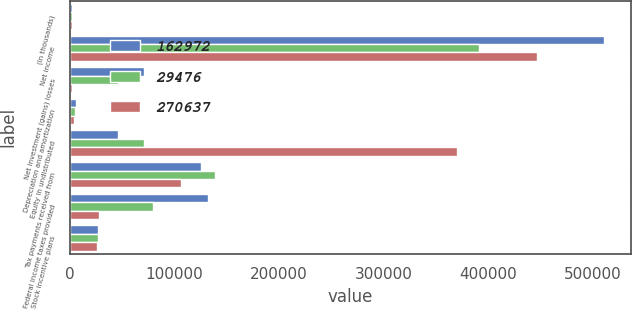<chart> <loc_0><loc_0><loc_500><loc_500><stacked_bar_chart><ecel><fcel>(In thousands)<fcel>Net income<fcel>Net investment (gains) losses<fcel>Depreciation and amortization<fcel>Equity in undistributed<fcel>Tax payments received from<fcel>Federal income taxes provided<fcel>Stock incentive plans<nl><fcel>162972<fcel>2012<fcel>510592<fcel>71130<fcel>5624<fcel>45962<fcel>125046<fcel>132379<fcel>26763<nl><fcel>29476<fcel>2011<fcel>391211<fcel>45962<fcel>4905<fcel>71146<fcel>139011<fcel>79200<fcel>27176<nl><fcel>270637<fcel>2010<fcel>446405<fcel>1891<fcel>3963<fcel>369695<fcel>106284<fcel>28377<fcel>26318<nl></chart> 